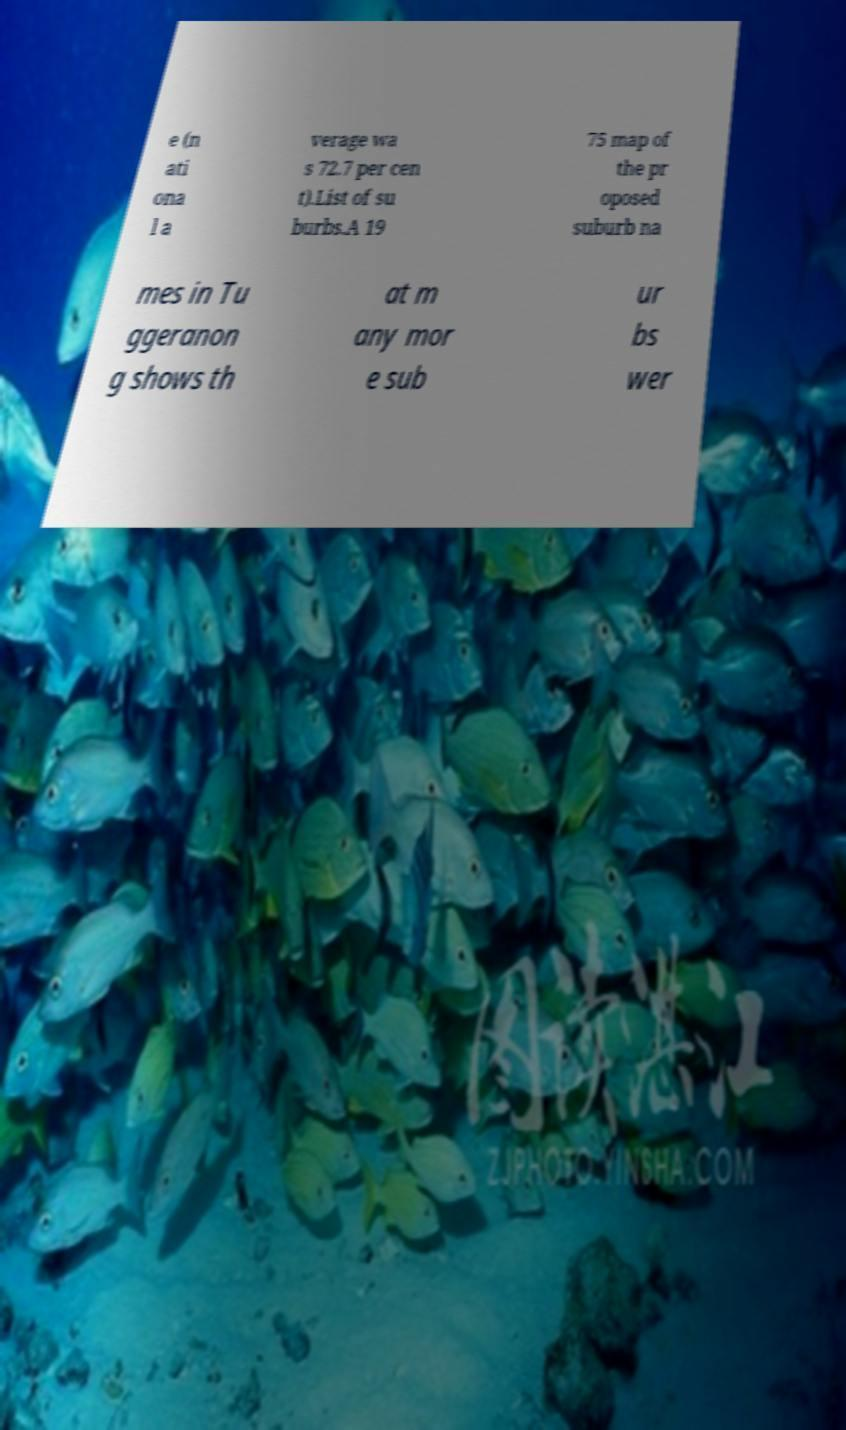What messages or text are displayed in this image? I need them in a readable, typed format. e (n ati ona l a verage wa s 72.7 per cen t).List of su burbs.A 19 75 map of the pr oposed suburb na mes in Tu ggeranon g shows th at m any mor e sub ur bs wer 